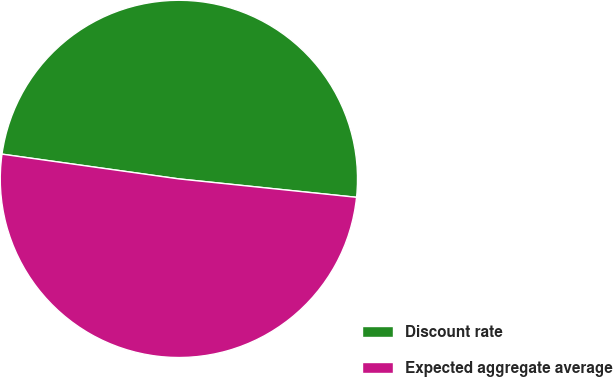Convert chart to OTSL. <chart><loc_0><loc_0><loc_500><loc_500><pie_chart><fcel>Discount rate<fcel>Expected aggregate average<nl><fcel>49.43%<fcel>50.57%<nl></chart> 